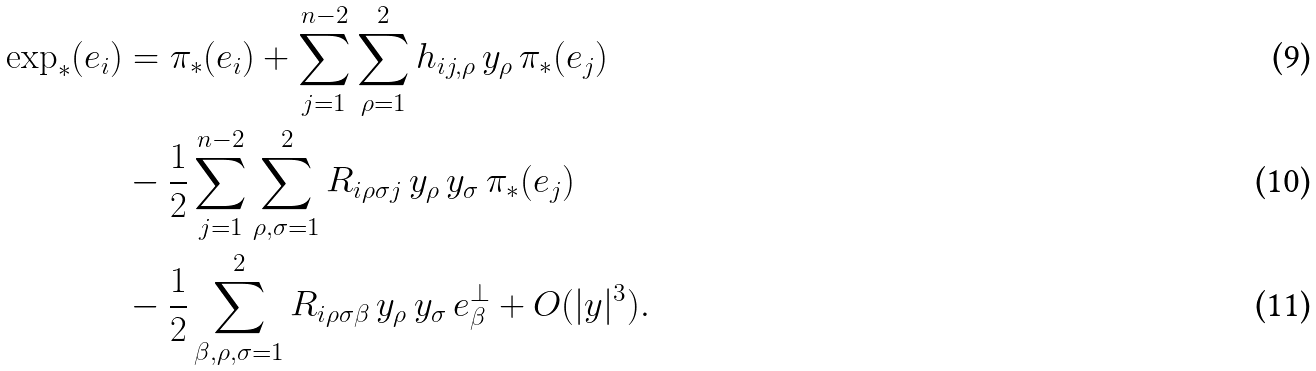Convert formula to latex. <formula><loc_0><loc_0><loc_500><loc_500>\exp _ { * } ( e _ { i } ) & = \pi _ { * } ( e _ { i } ) + \sum _ { j = 1 } ^ { n - 2 } \sum _ { \rho = 1 } ^ { 2 } h _ { i j , \rho } \, y _ { \rho } \, \pi _ { * } ( e _ { j } ) \\ & - \frac { 1 } { 2 } \sum _ { j = 1 } ^ { n - 2 } \sum _ { \rho , \sigma = 1 } ^ { 2 } R _ { i \rho \sigma j } \, y _ { \rho } \, y _ { \sigma } \, \pi _ { * } ( e _ { j } ) \\ & - \frac { 1 } { 2 } \sum _ { \beta , \rho , \sigma = 1 } ^ { 2 } R _ { i \rho \sigma \beta } \, y _ { \rho } \, y _ { \sigma } \, e ^ { \perp } _ { \beta } + O ( | y | ^ { 3 } ) .</formula> 